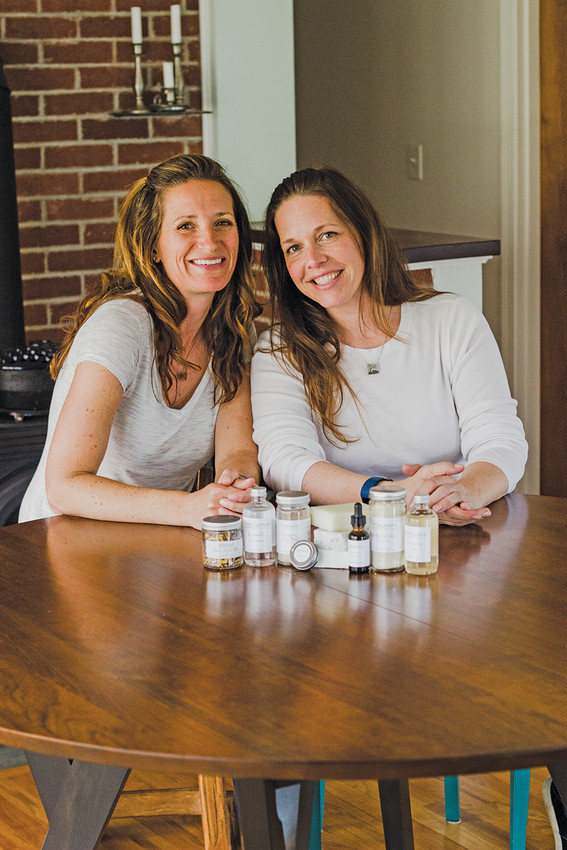If you were to imagine the two individuals preparing for a product launch event, how would you describe the atmosphere and their preparations? In preparation for a product launch event, the atmosphere would likely be one of excitement and meticulous attention to detail. The two individuals might be organizing their products, setting up displays, and rehearsing their presentation. They could be checking the quality of each item and ensuring that their space reflects the clean and natural aesthetics of their brand. The preparations would involve a mixture of creative brainstorming and practical tasks, all carried out with a sense of shared purpose and enthusiasm. They might gather marketing materials, plan engaging customer interactions, and make sure every aspect of the event aligns with their brand identity. What kind of challenges could they face during this launch, and how might they overcome them? During the launch, they might face challenges such as technical difficulties, last-minute product issues, or managing customer inquiries. To overcome these, they could prepare by having backups of their presentations, ensuring all products are double-checked, and possibly hiring additional staff to help manage the event. They would rely on their strong partnership, clear communication, and thorough planning to tackle any issues that arise. Their enthusiasm and genuine passion for their products would also help them navigate any hurdles, maintaining a positive and professional atmosphere throughout the event. 